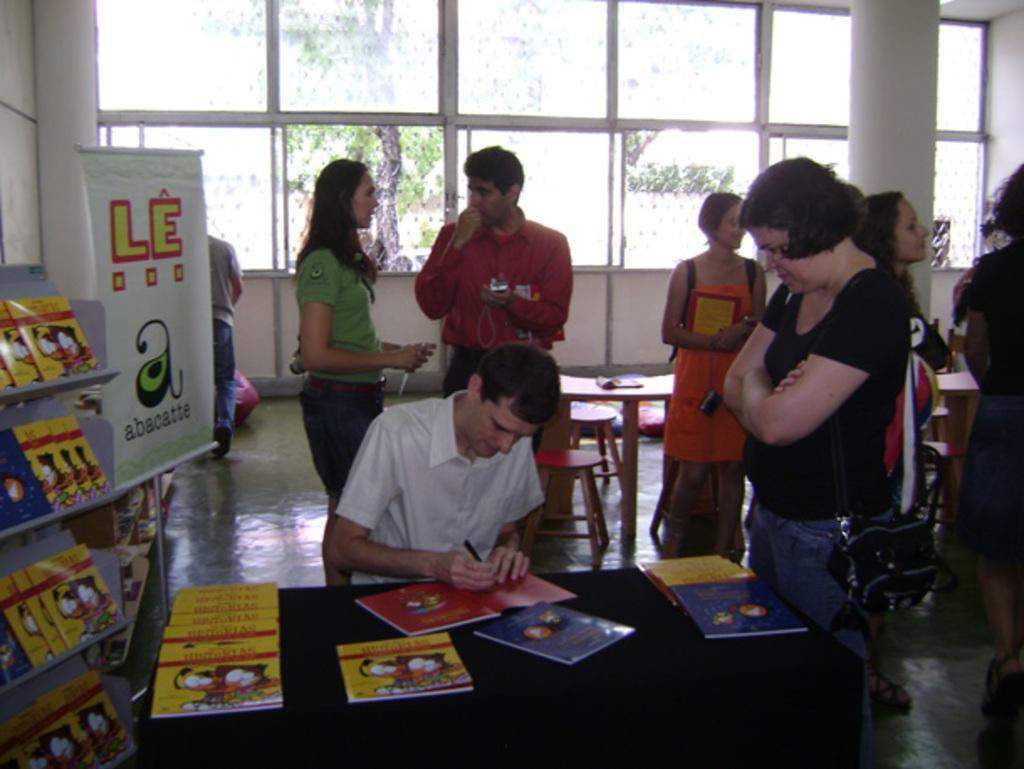Please provide a concise description of this image. In this image there is a table, on that table there are books, behind the table there is a man sitting on a chair, in the background there are people standing, there are tables and chairs and there is a wall for that wall there are glass windows, on the left side there is a rack on that rack, there are books and there is a banner, on that banner there is some text. 